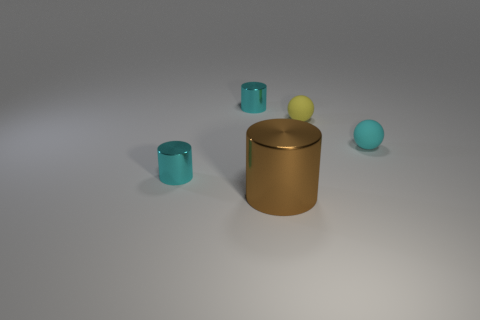Add 3 small spheres. How many objects exist? 8 Subtract all cylinders. How many objects are left? 2 Subtract 0 brown cubes. How many objects are left? 5 Subtract all small cyan matte balls. Subtract all cyan shiny cylinders. How many objects are left? 2 Add 2 large objects. How many large objects are left? 3 Add 2 tiny red matte cubes. How many tiny red matte cubes exist? 2 